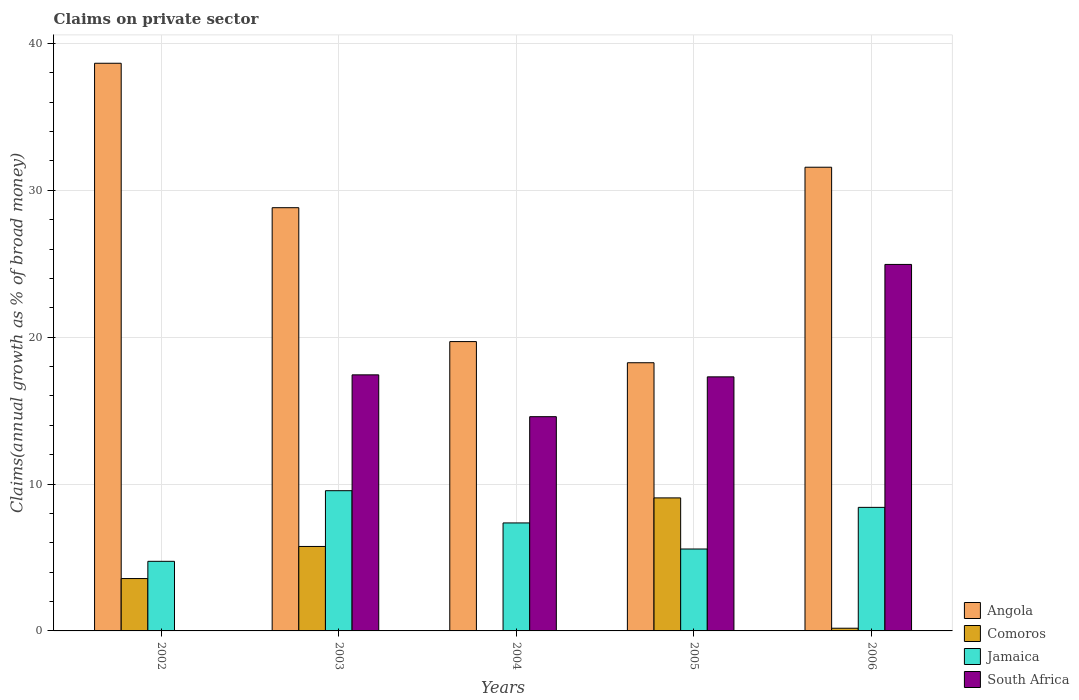How many groups of bars are there?
Keep it short and to the point. 5. How many bars are there on the 3rd tick from the right?
Give a very brief answer. 3. What is the label of the 1st group of bars from the left?
Offer a very short reply. 2002. What is the percentage of broad money claimed on private sector in Angola in 2002?
Your answer should be very brief. 38.65. Across all years, what is the maximum percentage of broad money claimed on private sector in South Africa?
Offer a very short reply. 24.95. Across all years, what is the minimum percentage of broad money claimed on private sector in South Africa?
Provide a short and direct response. 0. In which year was the percentage of broad money claimed on private sector in Jamaica maximum?
Ensure brevity in your answer.  2003. What is the total percentage of broad money claimed on private sector in South Africa in the graph?
Your response must be concise. 74.28. What is the difference between the percentage of broad money claimed on private sector in Angola in 2002 and that in 2005?
Give a very brief answer. 20.39. What is the difference between the percentage of broad money claimed on private sector in Angola in 2003 and the percentage of broad money claimed on private sector in Comoros in 2006?
Ensure brevity in your answer.  28.63. What is the average percentage of broad money claimed on private sector in South Africa per year?
Your answer should be compact. 14.86. In the year 2003, what is the difference between the percentage of broad money claimed on private sector in South Africa and percentage of broad money claimed on private sector in Angola?
Ensure brevity in your answer.  -11.38. In how many years, is the percentage of broad money claimed on private sector in Comoros greater than 34 %?
Your answer should be compact. 0. What is the ratio of the percentage of broad money claimed on private sector in Jamaica in 2002 to that in 2004?
Your response must be concise. 0.64. Is the percentage of broad money claimed on private sector in Angola in 2004 less than that in 2005?
Provide a succinct answer. No. Is the difference between the percentage of broad money claimed on private sector in South Africa in 2005 and 2006 greater than the difference between the percentage of broad money claimed on private sector in Angola in 2005 and 2006?
Your answer should be very brief. Yes. What is the difference between the highest and the second highest percentage of broad money claimed on private sector in Comoros?
Ensure brevity in your answer.  3.31. What is the difference between the highest and the lowest percentage of broad money claimed on private sector in Jamaica?
Make the answer very short. 4.81. In how many years, is the percentage of broad money claimed on private sector in Jamaica greater than the average percentage of broad money claimed on private sector in Jamaica taken over all years?
Keep it short and to the point. 3. Is it the case that in every year, the sum of the percentage of broad money claimed on private sector in Comoros and percentage of broad money claimed on private sector in South Africa is greater than the sum of percentage of broad money claimed on private sector in Jamaica and percentage of broad money claimed on private sector in Angola?
Your answer should be compact. No. Is it the case that in every year, the sum of the percentage of broad money claimed on private sector in South Africa and percentage of broad money claimed on private sector in Jamaica is greater than the percentage of broad money claimed on private sector in Angola?
Make the answer very short. No. Are all the bars in the graph horizontal?
Make the answer very short. No. How many years are there in the graph?
Make the answer very short. 5. Are the values on the major ticks of Y-axis written in scientific E-notation?
Offer a terse response. No. Where does the legend appear in the graph?
Ensure brevity in your answer.  Bottom right. How are the legend labels stacked?
Make the answer very short. Vertical. What is the title of the graph?
Ensure brevity in your answer.  Claims on private sector. What is the label or title of the Y-axis?
Offer a very short reply. Claims(annual growth as % of broad money). What is the Claims(annual growth as % of broad money) of Angola in 2002?
Give a very brief answer. 38.65. What is the Claims(annual growth as % of broad money) of Comoros in 2002?
Give a very brief answer. 3.57. What is the Claims(annual growth as % of broad money) in Jamaica in 2002?
Your answer should be compact. 4.74. What is the Claims(annual growth as % of broad money) in Angola in 2003?
Keep it short and to the point. 28.82. What is the Claims(annual growth as % of broad money) in Comoros in 2003?
Offer a very short reply. 5.75. What is the Claims(annual growth as % of broad money) of Jamaica in 2003?
Provide a succinct answer. 9.55. What is the Claims(annual growth as % of broad money) in South Africa in 2003?
Ensure brevity in your answer.  17.44. What is the Claims(annual growth as % of broad money) of Angola in 2004?
Your response must be concise. 19.7. What is the Claims(annual growth as % of broad money) in Jamaica in 2004?
Offer a terse response. 7.35. What is the Claims(annual growth as % of broad money) of South Africa in 2004?
Offer a very short reply. 14.59. What is the Claims(annual growth as % of broad money) in Angola in 2005?
Your answer should be very brief. 18.26. What is the Claims(annual growth as % of broad money) in Comoros in 2005?
Your answer should be compact. 9.06. What is the Claims(annual growth as % of broad money) in Jamaica in 2005?
Ensure brevity in your answer.  5.58. What is the Claims(annual growth as % of broad money) of South Africa in 2005?
Provide a succinct answer. 17.3. What is the Claims(annual growth as % of broad money) of Angola in 2006?
Provide a short and direct response. 31.57. What is the Claims(annual growth as % of broad money) of Comoros in 2006?
Give a very brief answer. 0.18. What is the Claims(annual growth as % of broad money) of Jamaica in 2006?
Your response must be concise. 8.41. What is the Claims(annual growth as % of broad money) in South Africa in 2006?
Give a very brief answer. 24.95. Across all years, what is the maximum Claims(annual growth as % of broad money) in Angola?
Your answer should be very brief. 38.65. Across all years, what is the maximum Claims(annual growth as % of broad money) of Comoros?
Give a very brief answer. 9.06. Across all years, what is the maximum Claims(annual growth as % of broad money) of Jamaica?
Ensure brevity in your answer.  9.55. Across all years, what is the maximum Claims(annual growth as % of broad money) of South Africa?
Your answer should be compact. 24.95. Across all years, what is the minimum Claims(annual growth as % of broad money) in Angola?
Your response must be concise. 18.26. Across all years, what is the minimum Claims(annual growth as % of broad money) of Comoros?
Provide a short and direct response. 0. Across all years, what is the minimum Claims(annual growth as % of broad money) in Jamaica?
Your answer should be very brief. 4.74. Across all years, what is the minimum Claims(annual growth as % of broad money) in South Africa?
Provide a short and direct response. 0. What is the total Claims(annual growth as % of broad money) of Angola in the graph?
Provide a succinct answer. 137.01. What is the total Claims(annual growth as % of broad money) in Comoros in the graph?
Ensure brevity in your answer.  18.56. What is the total Claims(annual growth as % of broad money) of Jamaica in the graph?
Your answer should be compact. 35.63. What is the total Claims(annual growth as % of broad money) of South Africa in the graph?
Your answer should be compact. 74.28. What is the difference between the Claims(annual growth as % of broad money) in Angola in 2002 and that in 2003?
Keep it short and to the point. 9.83. What is the difference between the Claims(annual growth as % of broad money) of Comoros in 2002 and that in 2003?
Give a very brief answer. -2.19. What is the difference between the Claims(annual growth as % of broad money) of Jamaica in 2002 and that in 2003?
Your answer should be very brief. -4.81. What is the difference between the Claims(annual growth as % of broad money) in Angola in 2002 and that in 2004?
Your answer should be compact. 18.95. What is the difference between the Claims(annual growth as % of broad money) of Jamaica in 2002 and that in 2004?
Your response must be concise. -2.61. What is the difference between the Claims(annual growth as % of broad money) of Angola in 2002 and that in 2005?
Provide a short and direct response. 20.39. What is the difference between the Claims(annual growth as % of broad money) of Comoros in 2002 and that in 2005?
Make the answer very short. -5.49. What is the difference between the Claims(annual growth as % of broad money) in Jamaica in 2002 and that in 2005?
Provide a short and direct response. -0.84. What is the difference between the Claims(annual growth as % of broad money) of Angola in 2002 and that in 2006?
Keep it short and to the point. 7.08. What is the difference between the Claims(annual growth as % of broad money) in Comoros in 2002 and that in 2006?
Provide a short and direct response. 3.38. What is the difference between the Claims(annual growth as % of broad money) of Jamaica in 2002 and that in 2006?
Provide a short and direct response. -3.67. What is the difference between the Claims(annual growth as % of broad money) in Angola in 2003 and that in 2004?
Make the answer very short. 9.12. What is the difference between the Claims(annual growth as % of broad money) in Jamaica in 2003 and that in 2004?
Keep it short and to the point. 2.19. What is the difference between the Claims(annual growth as % of broad money) in South Africa in 2003 and that in 2004?
Your response must be concise. 2.85. What is the difference between the Claims(annual growth as % of broad money) in Angola in 2003 and that in 2005?
Ensure brevity in your answer.  10.56. What is the difference between the Claims(annual growth as % of broad money) in Comoros in 2003 and that in 2005?
Your answer should be compact. -3.31. What is the difference between the Claims(annual growth as % of broad money) in Jamaica in 2003 and that in 2005?
Your answer should be compact. 3.97. What is the difference between the Claims(annual growth as % of broad money) of South Africa in 2003 and that in 2005?
Give a very brief answer. 0.14. What is the difference between the Claims(annual growth as % of broad money) of Angola in 2003 and that in 2006?
Provide a short and direct response. -2.75. What is the difference between the Claims(annual growth as % of broad money) of Comoros in 2003 and that in 2006?
Your response must be concise. 5.57. What is the difference between the Claims(annual growth as % of broad money) in Jamaica in 2003 and that in 2006?
Provide a succinct answer. 1.14. What is the difference between the Claims(annual growth as % of broad money) of South Africa in 2003 and that in 2006?
Provide a succinct answer. -7.52. What is the difference between the Claims(annual growth as % of broad money) of Angola in 2004 and that in 2005?
Offer a terse response. 1.44. What is the difference between the Claims(annual growth as % of broad money) in Jamaica in 2004 and that in 2005?
Provide a succinct answer. 1.78. What is the difference between the Claims(annual growth as % of broad money) in South Africa in 2004 and that in 2005?
Make the answer very short. -2.71. What is the difference between the Claims(annual growth as % of broad money) of Angola in 2004 and that in 2006?
Offer a terse response. -11.87. What is the difference between the Claims(annual growth as % of broad money) of Jamaica in 2004 and that in 2006?
Ensure brevity in your answer.  -1.06. What is the difference between the Claims(annual growth as % of broad money) in South Africa in 2004 and that in 2006?
Ensure brevity in your answer.  -10.37. What is the difference between the Claims(annual growth as % of broad money) in Angola in 2005 and that in 2006?
Provide a short and direct response. -13.31. What is the difference between the Claims(annual growth as % of broad money) of Comoros in 2005 and that in 2006?
Offer a very short reply. 8.87. What is the difference between the Claims(annual growth as % of broad money) in Jamaica in 2005 and that in 2006?
Your response must be concise. -2.84. What is the difference between the Claims(annual growth as % of broad money) of South Africa in 2005 and that in 2006?
Your response must be concise. -7.66. What is the difference between the Claims(annual growth as % of broad money) in Angola in 2002 and the Claims(annual growth as % of broad money) in Comoros in 2003?
Provide a short and direct response. 32.9. What is the difference between the Claims(annual growth as % of broad money) in Angola in 2002 and the Claims(annual growth as % of broad money) in Jamaica in 2003?
Give a very brief answer. 29.1. What is the difference between the Claims(annual growth as % of broad money) in Angola in 2002 and the Claims(annual growth as % of broad money) in South Africa in 2003?
Your response must be concise. 21.22. What is the difference between the Claims(annual growth as % of broad money) of Comoros in 2002 and the Claims(annual growth as % of broad money) of Jamaica in 2003?
Provide a succinct answer. -5.98. What is the difference between the Claims(annual growth as % of broad money) in Comoros in 2002 and the Claims(annual growth as % of broad money) in South Africa in 2003?
Your answer should be very brief. -13.87. What is the difference between the Claims(annual growth as % of broad money) in Jamaica in 2002 and the Claims(annual growth as % of broad money) in South Africa in 2003?
Your answer should be very brief. -12.7. What is the difference between the Claims(annual growth as % of broad money) in Angola in 2002 and the Claims(annual growth as % of broad money) in Jamaica in 2004?
Offer a terse response. 31.3. What is the difference between the Claims(annual growth as % of broad money) of Angola in 2002 and the Claims(annual growth as % of broad money) of South Africa in 2004?
Offer a terse response. 24.06. What is the difference between the Claims(annual growth as % of broad money) in Comoros in 2002 and the Claims(annual growth as % of broad money) in Jamaica in 2004?
Your answer should be compact. -3.79. What is the difference between the Claims(annual growth as % of broad money) in Comoros in 2002 and the Claims(annual growth as % of broad money) in South Africa in 2004?
Offer a very short reply. -11.02. What is the difference between the Claims(annual growth as % of broad money) in Jamaica in 2002 and the Claims(annual growth as % of broad money) in South Africa in 2004?
Your answer should be compact. -9.85. What is the difference between the Claims(annual growth as % of broad money) of Angola in 2002 and the Claims(annual growth as % of broad money) of Comoros in 2005?
Your response must be concise. 29.6. What is the difference between the Claims(annual growth as % of broad money) in Angola in 2002 and the Claims(annual growth as % of broad money) in Jamaica in 2005?
Offer a very short reply. 33.07. What is the difference between the Claims(annual growth as % of broad money) in Angola in 2002 and the Claims(annual growth as % of broad money) in South Africa in 2005?
Ensure brevity in your answer.  21.35. What is the difference between the Claims(annual growth as % of broad money) in Comoros in 2002 and the Claims(annual growth as % of broad money) in Jamaica in 2005?
Provide a succinct answer. -2.01. What is the difference between the Claims(annual growth as % of broad money) of Comoros in 2002 and the Claims(annual growth as % of broad money) of South Africa in 2005?
Provide a succinct answer. -13.73. What is the difference between the Claims(annual growth as % of broad money) in Jamaica in 2002 and the Claims(annual growth as % of broad money) in South Africa in 2005?
Your answer should be very brief. -12.56. What is the difference between the Claims(annual growth as % of broad money) of Angola in 2002 and the Claims(annual growth as % of broad money) of Comoros in 2006?
Your response must be concise. 38.47. What is the difference between the Claims(annual growth as % of broad money) of Angola in 2002 and the Claims(annual growth as % of broad money) of Jamaica in 2006?
Provide a short and direct response. 30.24. What is the difference between the Claims(annual growth as % of broad money) in Angola in 2002 and the Claims(annual growth as % of broad money) in South Africa in 2006?
Make the answer very short. 13.7. What is the difference between the Claims(annual growth as % of broad money) of Comoros in 2002 and the Claims(annual growth as % of broad money) of Jamaica in 2006?
Keep it short and to the point. -4.85. What is the difference between the Claims(annual growth as % of broad money) of Comoros in 2002 and the Claims(annual growth as % of broad money) of South Africa in 2006?
Your answer should be compact. -21.39. What is the difference between the Claims(annual growth as % of broad money) of Jamaica in 2002 and the Claims(annual growth as % of broad money) of South Africa in 2006?
Give a very brief answer. -20.22. What is the difference between the Claims(annual growth as % of broad money) in Angola in 2003 and the Claims(annual growth as % of broad money) in Jamaica in 2004?
Make the answer very short. 21.46. What is the difference between the Claims(annual growth as % of broad money) of Angola in 2003 and the Claims(annual growth as % of broad money) of South Africa in 2004?
Provide a short and direct response. 14.23. What is the difference between the Claims(annual growth as % of broad money) in Comoros in 2003 and the Claims(annual growth as % of broad money) in Jamaica in 2004?
Make the answer very short. -1.6. What is the difference between the Claims(annual growth as % of broad money) of Comoros in 2003 and the Claims(annual growth as % of broad money) of South Africa in 2004?
Keep it short and to the point. -8.84. What is the difference between the Claims(annual growth as % of broad money) in Jamaica in 2003 and the Claims(annual growth as % of broad money) in South Africa in 2004?
Give a very brief answer. -5.04. What is the difference between the Claims(annual growth as % of broad money) in Angola in 2003 and the Claims(annual growth as % of broad money) in Comoros in 2005?
Give a very brief answer. 19.76. What is the difference between the Claims(annual growth as % of broad money) in Angola in 2003 and the Claims(annual growth as % of broad money) in Jamaica in 2005?
Offer a terse response. 23.24. What is the difference between the Claims(annual growth as % of broad money) of Angola in 2003 and the Claims(annual growth as % of broad money) of South Africa in 2005?
Provide a short and direct response. 11.52. What is the difference between the Claims(annual growth as % of broad money) in Comoros in 2003 and the Claims(annual growth as % of broad money) in Jamaica in 2005?
Your answer should be compact. 0.17. What is the difference between the Claims(annual growth as % of broad money) in Comoros in 2003 and the Claims(annual growth as % of broad money) in South Africa in 2005?
Your answer should be very brief. -11.55. What is the difference between the Claims(annual growth as % of broad money) of Jamaica in 2003 and the Claims(annual growth as % of broad money) of South Africa in 2005?
Your answer should be very brief. -7.75. What is the difference between the Claims(annual growth as % of broad money) in Angola in 2003 and the Claims(annual growth as % of broad money) in Comoros in 2006?
Provide a succinct answer. 28.63. What is the difference between the Claims(annual growth as % of broad money) of Angola in 2003 and the Claims(annual growth as % of broad money) of Jamaica in 2006?
Offer a very short reply. 20.41. What is the difference between the Claims(annual growth as % of broad money) in Angola in 2003 and the Claims(annual growth as % of broad money) in South Africa in 2006?
Provide a short and direct response. 3.86. What is the difference between the Claims(annual growth as % of broad money) in Comoros in 2003 and the Claims(annual growth as % of broad money) in Jamaica in 2006?
Ensure brevity in your answer.  -2.66. What is the difference between the Claims(annual growth as % of broad money) in Comoros in 2003 and the Claims(annual growth as % of broad money) in South Africa in 2006?
Your answer should be very brief. -19.2. What is the difference between the Claims(annual growth as % of broad money) of Jamaica in 2003 and the Claims(annual growth as % of broad money) of South Africa in 2006?
Provide a succinct answer. -15.41. What is the difference between the Claims(annual growth as % of broad money) in Angola in 2004 and the Claims(annual growth as % of broad money) in Comoros in 2005?
Offer a very short reply. 10.64. What is the difference between the Claims(annual growth as % of broad money) in Angola in 2004 and the Claims(annual growth as % of broad money) in Jamaica in 2005?
Your answer should be compact. 14.12. What is the difference between the Claims(annual growth as % of broad money) of Angola in 2004 and the Claims(annual growth as % of broad money) of South Africa in 2005?
Make the answer very short. 2.4. What is the difference between the Claims(annual growth as % of broad money) of Jamaica in 2004 and the Claims(annual growth as % of broad money) of South Africa in 2005?
Ensure brevity in your answer.  -9.95. What is the difference between the Claims(annual growth as % of broad money) in Angola in 2004 and the Claims(annual growth as % of broad money) in Comoros in 2006?
Provide a short and direct response. 19.52. What is the difference between the Claims(annual growth as % of broad money) in Angola in 2004 and the Claims(annual growth as % of broad money) in Jamaica in 2006?
Provide a succinct answer. 11.29. What is the difference between the Claims(annual growth as % of broad money) of Angola in 2004 and the Claims(annual growth as % of broad money) of South Africa in 2006?
Provide a short and direct response. -5.25. What is the difference between the Claims(annual growth as % of broad money) of Jamaica in 2004 and the Claims(annual growth as % of broad money) of South Africa in 2006?
Give a very brief answer. -17.6. What is the difference between the Claims(annual growth as % of broad money) of Angola in 2005 and the Claims(annual growth as % of broad money) of Comoros in 2006?
Offer a terse response. 18.08. What is the difference between the Claims(annual growth as % of broad money) in Angola in 2005 and the Claims(annual growth as % of broad money) in Jamaica in 2006?
Provide a short and direct response. 9.85. What is the difference between the Claims(annual growth as % of broad money) of Angola in 2005 and the Claims(annual growth as % of broad money) of South Africa in 2006?
Your answer should be compact. -6.69. What is the difference between the Claims(annual growth as % of broad money) of Comoros in 2005 and the Claims(annual growth as % of broad money) of Jamaica in 2006?
Give a very brief answer. 0.64. What is the difference between the Claims(annual growth as % of broad money) of Comoros in 2005 and the Claims(annual growth as % of broad money) of South Africa in 2006?
Give a very brief answer. -15.9. What is the difference between the Claims(annual growth as % of broad money) of Jamaica in 2005 and the Claims(annual growth as % of broad money) of South Africa in 2006?
Offer a very short reply. -19.38. What is the average Claims(annual growth as % of broad money) of Angola per year?
Your answer should be compact. 27.4. What is the average Claims(annual growth as % of broad money) of Comoros per year?
Give a very brief answer. 3.71. What is the average Claims(annual growth as % of broad money) in Jamaica per year?
Provide a short and direct response. 7.13. What is the average Claims(annual growth as % of broad money) in South Africa per year?
Make the answer very short. 14.86. In the year 2002, what is the difference between the Claims(annual growth as % of broad money) of Angola and Claims(annual growth as % of broad money) of Comoros?
Give a very brief answer. 35.09. In the year 2002, what is the difference between the Claims(annual growth as % of broad money) of Angola and Claims(annual growth as % of broad money) of Jamaica?
Offer a terse response. 33.91. In the year 2002, what is the difference between the Claims(annual growth as % of broad money) of Comoros and Claims(annual growth as % of broad money) of Jamaica?
Give a very brief answer. -1.17. In the year 2003, what is the difference between the Claims(annual growth as % of broad money) in Angola and Claims(annual growth as % of broad money) in Comoros?
Offer a terse response. 23.07. In the year 2003, what is the difference between the Claims(annual growth as % of broad money) in Angola and Claims(annual growth as % of broad money) in Jamaica?
Your answer should be compact. 19.27. In the year 2003, what is the difference between the Claims(annual growth as % of broad money) in Angola and Claims(annual growth as % of broad money) in South Africa?
Ensure brevity in your answer.  11.38. In the year 2003, what is the difference between the Claims(annual growth as % of broad money) of Comoros and Claims(annual growth as % of broad money) of Jamaica?
Keep it short and to the point. -3.8. In the year 2003, what is the difference between the Claims(annual growth as % of broad money) of Comoros and Claims(annual growth as % of broad money) of South Africa?
Provide a succinct answer. -11.68. In the year 2003, what is the difference between the Claims(annual growth as % of broad money) in Jamaica and Claims(annual growth as % of broad money) in South Africa?
Offer a very short reply. -7.89. In the year 2004, what is the difference between the Claims(annual growth as % of broad money) in Angola and Claims(annual growth as % of broad money) in Jamaica?
Offer a terse response. 12.35. In the year 2004, what is the difference between the Claims(annual growth as % of broad money) in Angola and Claims(annual growth as % of broad money) in South Africa?
Keep it short and to the point. 5.11. In the year 2004, what is the difference between the Claims(annual growth as % of broad money) of Jamaica and Claims(annual growth as % of broad money) of South Africa?
Offer a terse response. -7.23. In the year 2005, what is the difference between the Claims(annual growth as % of broad money) in Angola and Claims(annual growth as % of broad money) in Comoros?
Provide a short and direct response. 9.2. In the year 2005, what is the difference between the Claims(annual growth as % of broad money) of Angola and Claims(annual growth as % of broad money) of Jamaica?
Your answer should be compact. 12.68. In the year 2005, what is the difference between the Claims(annual growth as % of broad money) in Angola and Claims(annual growth as % of broad money) in South Africa?
Keep it short and to the point. 0.96. In the year 2005, what is the difference between the Claims(annual growth as % of broad money) in Comoros and Claims(annual growth as % of broad money) in Jamaica?
Ensure brevity in your answer.  3.48. In the year 2005, what is the difference between the Claims(annual growth as % of broad money) of Comoros and Claims(annual growth as % of broad money) of South Africa?
Your response must be concise. -8.24. In the year 2005, what is the difference between the Claims(annual growth as % of broad money) in Jamaica and Claims(annual growth as % of broad money) in South Africa?
Provide a succinct answer. -11.72. In the year 2006, what is the difference between the Claims(annual growth as % of broad money) of Angola and Claims(annual growth as % of broad money) of Comoros?
Give a very brief answer. 31.39. In the year 2006, what is the difference between the Claims(annual growth as % of broad money) in Angola and Claims(annual growth as % of broad money) in Jamaica?
Keep it short and to the point. 23.16. In the year 2006, what is the difference between the Claims(annual growth as % of broad money) in Angola and Claims(annual growth as % of broad money) in South Africa?
Ensure brevity in your answer.  6.62. In the year 2006, what is the difference between the Claims(annual growth as % of broad money) of Comoros and Claims(annual growth as % of broad money) of Jamaica?
Provide a succinct answer. -8.23. In the year 2006, what is the difference between the Claims(annual growth as % of broad money) in Comoros and Claims(annual growth as % of broad money) in South Africa?
Ensure brevity in your answer.  -24.77. In the year 2006, what is the difference between the Claims(annual growth as % of broad money) in Jamaica and Claims(annual growth as % of broad money) in South Africa?
Your answer should be very brief. -16.54. What is the ratio of the Claims(annual growth as % of broad money) of Angola in 2002 to that in 2003?
Your answer should be very brief. 1.34. What is the ratio of the Claims(annual growth as % of broad money) in Comoros in 2002 to that in 2003?
Your answer should be compact. 0.62. What is the ratio of the Claims(annual growth as % of broad money) in Jamaica in 2002 to that in 2003?
Make the answer very short. 0.5. What is the ratio of the Claims(annual growth as % of broad money) of Angola in 2002 to that in 2004?
Provide a short and direct response. 1.96. What is the ratio of the Claims(annual growth as % of broad money) of Jamaica in 2002 to that in 2004?
Offer a terse response. 0.64. What is the ratio of the Claims(annual growth as % of broad money) of Angola in 2002 to that in 2005?
Provide a succinct answer. 2.12. What is the ratio of the Claims(annual growth as % of broad money) of Comoros in 2002 to that in 2005?
Provide a short and direct response. 0.39. What is the ratio of the Claims(annual growth as % of broad money) of Jamaica in 2002 to that in 2005?
Make the answer very short. 0.85. What is the ratio of the Claims(annual growth as % of broad money) of Angola in 2002 to that in 2006?
Offer a very short reply. 1.22. What is the ratio of the Claims(annual growth as % of broad money) in Comoros in 2002 to that in 2006?
Your answer should be very brief. 19.44. What is the ratio of the Claims(annual growth as % of broad money) in Jamaica in 2002 to that in 2006?
Your answer should be very brief. 0.56. What is the ratio of the Claims(annual growth as % of broad money) of Angola in 2003 to that in 2004?
Make the answer very short. 1.46. What is the ratio of the Claims(annual growth as % of broad money) in Jamaica in 2003 to that in 2004?
Your response must be concise. 1.3. What is the ratio of the Claims(annual growth as % of broad money) of South Africa in 2003 to that in 2004?
Your response must be concise. 1.2. What is the ratio of the Claims(annual growth as % of broad money) in Angola in 2003 to that in 2005?
Your answer should be compact. 1.58. What is the ratio of the Claims(annual growth as % of broad money) of Comoros in 2003 to that in 2005?
Offer a very short reply. 0.64. What is the ratio of the Claims(annual growth as % of broad money) of Jamaica in 2003 to that in 2005?
Offer a terse response. 1.71. What is the ratio of the Claims(annual growth as % of broad money) in South Africa in 2003 to that in 2005?
Your answer should be compact. 1.01. What is the ratio of the Claims(annual growth as % of broad money) of Angola in 2003 to that in 2006?
Provide a short and direct response. 0.91. What is the ratio of the Claims(annual growth as % of broad money) in Comoros in 2003 to that in 2006?
Make the answer very short. 31.36. What is the ratio of the Claims(annual growth as % of broad money) in Jamaica in 2003 to that in 2006?
Your answer should be very brief. 1.13. What is the ratio of the Claims(annual growth as % of broad money) in South Africa in 2003 to that in 2006?
Offer a terse response. 0.7. What is the ratio of the Claims(annual growth as % of broad money) of Angola in 2004 to that in 2005?
Provide a succinct answer. 1.08. What is the ratio of the Claims(annual growth as % of broad money) of Jamaica in 2004 to that in 2005?
Your response must be concise. 1.32. What is the ratio of the Claims(annual growth as % of broad money) in South Africa in 2004 to that in 2005?
Make the answer very short. 0.84. What is the ratio of the Claims(annual growth as % of broad money) of Angola in 2004 to that in 2006?
Give a very brief answer. 0.62. What is the ratio of the Claims(annual growth as % of broad money) of Jamaica in 2004 to that in 2006?
Give a very brief answer. 0.87. What is the ratio of the Claims(annual growth as % of broad money) in South Africa in 2004 to that in 2006?
Keep it short and to the point. 0.58. What is the ratio of the Claims(annual growth as % of broad money) in Angola in 2005 to that in 2006?
Provide a succinct answer. 0.58. What is the ratio of the Claims(annual growth as % of broad money) of Comoros in 2005 to that in 2006?
Offer a terse response. 49.38. What is the ratio of the Claims(annual growth as % of broad money) of Jamaica in 2005 to that in 2006?
Ensure brevity in your answer.  0.66. What is the ratio of the Claims(annual growth as % of broad money) of South Africa in 2005 to that in 2006?
Provide a succinct answer. 0.69. What is the difference between the highest and the second highest Claims(annual growth as % of broad money) in Angola?
Your answer should be very brief. 7.08. What is the difference between the highest and the second highest Claims(annual growth as % of broad money) in Comoros?
Your response must be concise. 3.31. What is the difference between the highest and the second highest Claims(annual growth as % of broad money) of Jamaica?
Provide a short and direct response. 1.14. What is the difference between the highest and the second highest Claims(annual growth as % of broad money) of South Africa?
Your answer should be compact. 7.52. What is the difference between the highest and the lowest Claims(annual growth as % of broad money) of Angola?
Give a very brief answer. 20.39. What is the difference between the highest and the lowest Claims(annual growth as % of broad money) of Comoros?
Your answer should be compact. 9.06. What is the difference between the highest and the lowest Claims(annual growth as % of broad money) of Jamaica?
Offer a very short reply. 4.81. What is the difference between the highest and the lowest Claims(annual growth as % of broad money) of South Africa?
Ensure brevity in your answer.  24.95. 